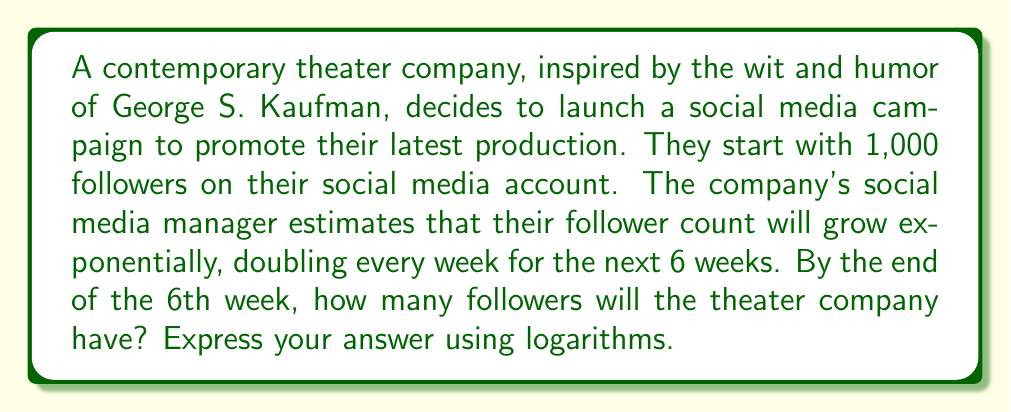Provide a solution to this math problem. Let's approach this step-by-step:

1) We start with 1,000 followers.
2) The number of followers doubles every week for 6 weeks.
3) We can express this as an exponential function:

   $f(t) = 1000 \cdot 2^t$, where $t$ is the number of weeks.

4) We want to find $f(6)$, the number of followers after 6 weeks.

5) $f(6) = 1000 \cdot 2^6 = 1000 \cdot 64 = 64,000$

6) To express this using logarithms, we can use the following property:
   
   If $y = b^x$, then $\log_b(y) = x$

7) In our case, we have $64,000 = 1000 \cdot 2^6$

8) Dividing both sides by 1000:
   
   $64 = 2^6$

9) Taking $\log_2$ of both sides:
   
   $\log_2(64) = 6$

Therefore, we can express the final number of followers as:

$1000 \cdot 2^{\log_2(64)} = 64,000$
Answer: $1000 \cdot 2^{\log_2(64)} = 64,000$ followers 